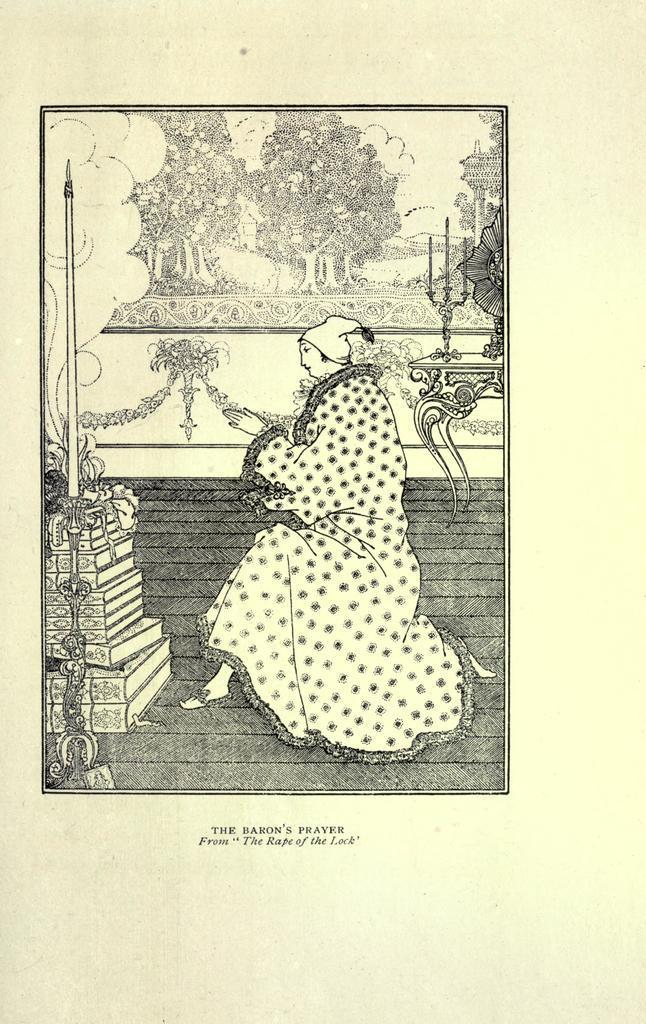In one or two sentences, can you explain what this image depicts? In this image we can see a paper with a person, books, table, candles, frame, wall, floor and also the text. 